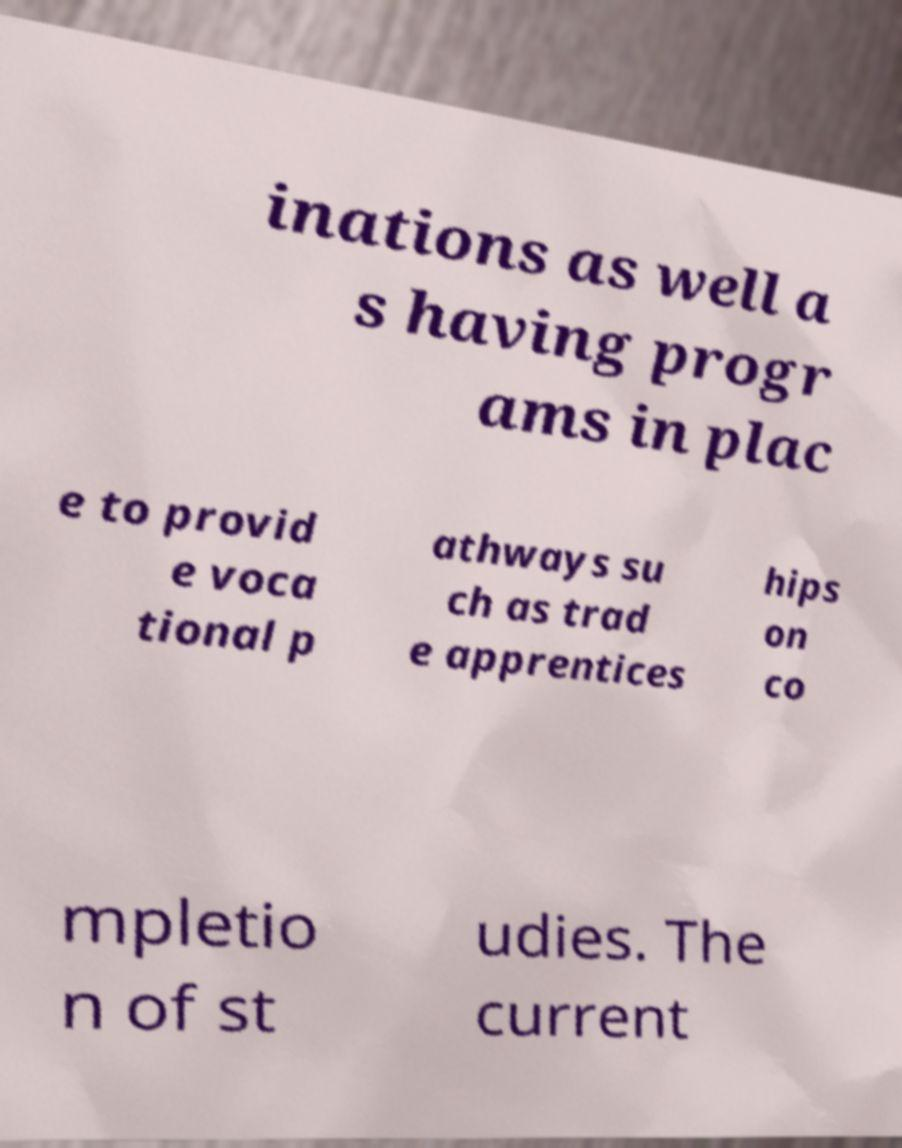I need the written content from this picture converted into text. Can you do that? inations as well a s having progr ams in plac e to provid e voca tional p athways su ch as trad e apprentices hips on co mpletio n of st udies. The current 